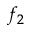<formula> <loc_0><loc_0><loc_500><loc_500>f _ { 2 }</formula> 